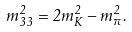Convert formula to latex. <formula><loc_0><loc_0><loc_500><loc_500>m ^ { 2 } _ { 3 3 } = 2 m ^ { 2 } _ { K } - m ^ { 2 } _ { \pi } .</formula> 